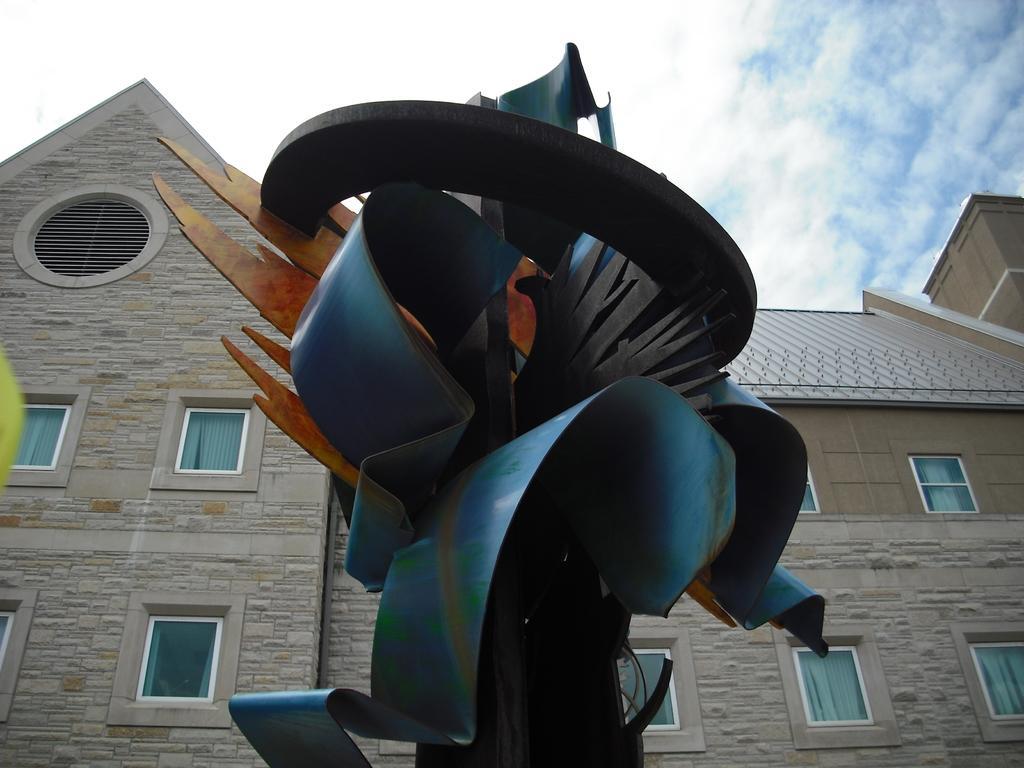How would you summarize this image in a sentence or two? In this image we can see a statue. In the background, we can see a building with a roof and group of windows and a cloudy sky. 